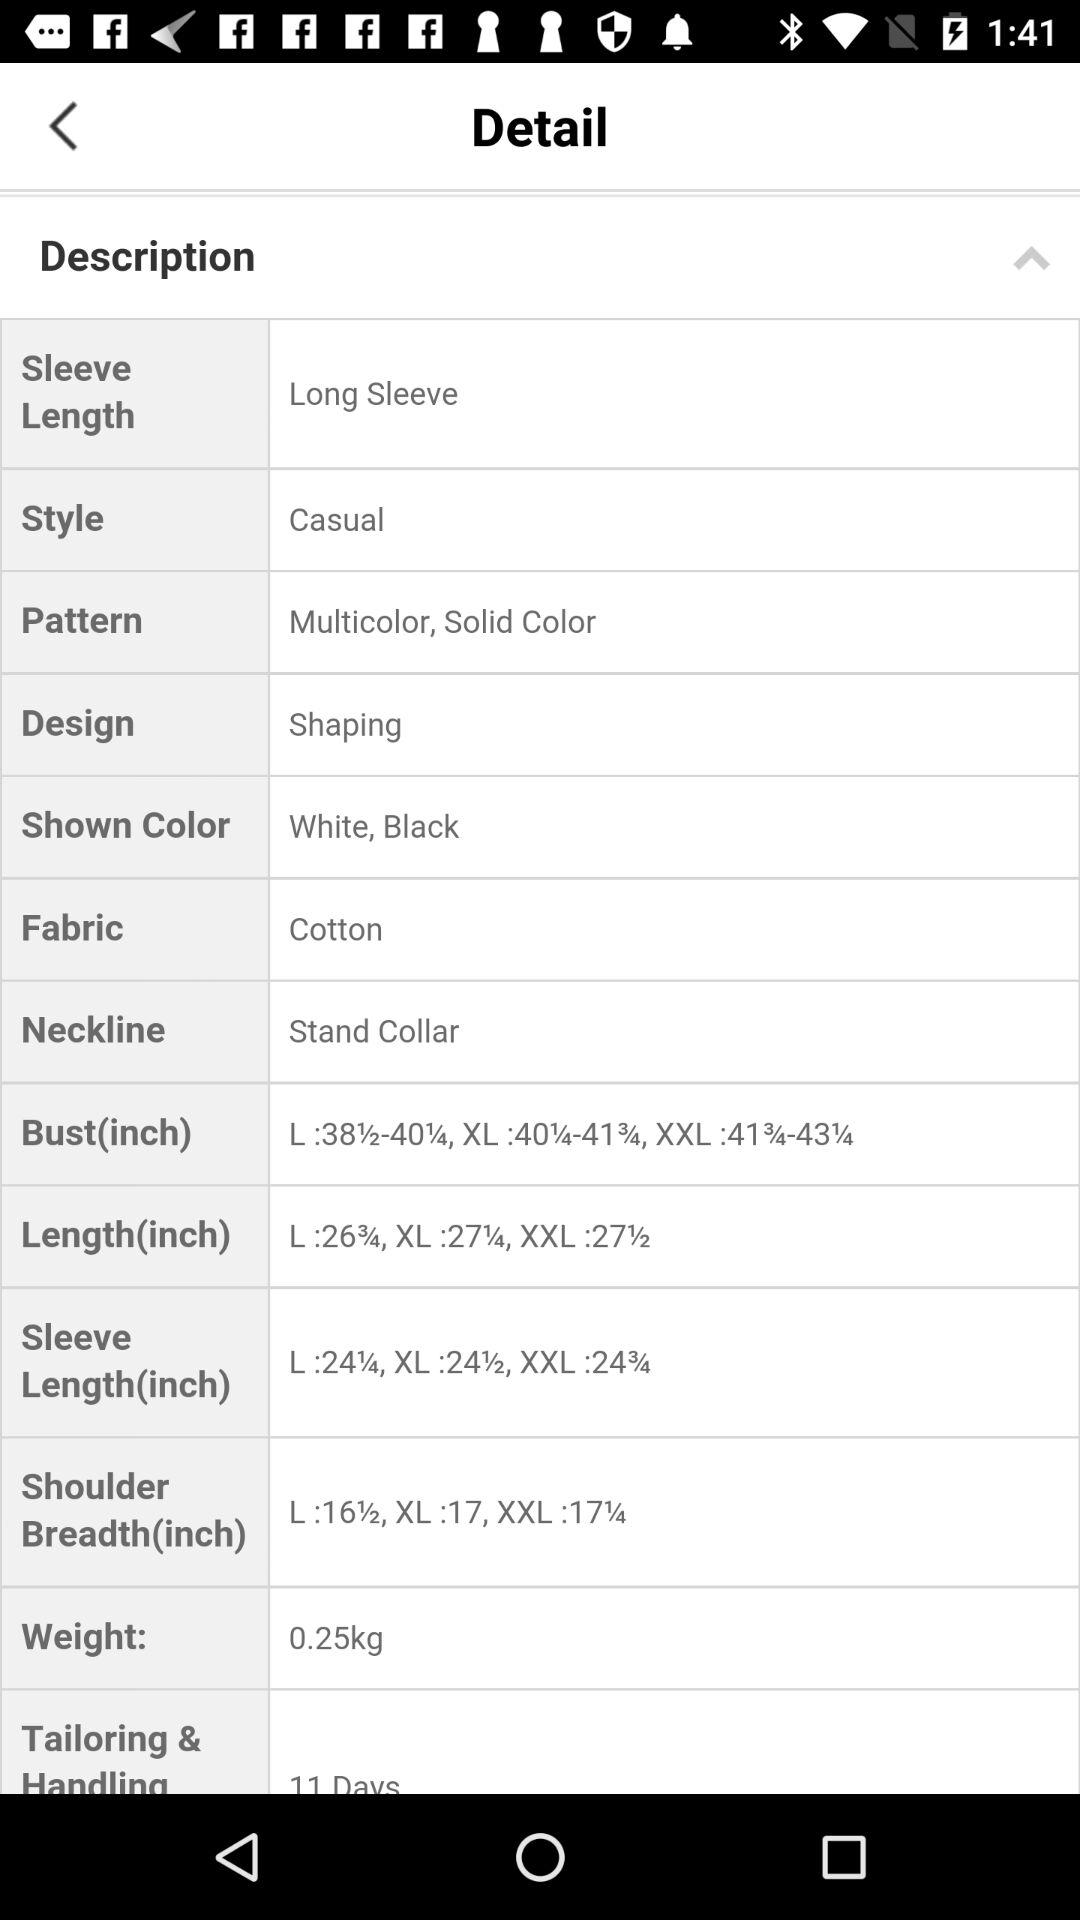What is the selected design? The selected design is "Shaping". 